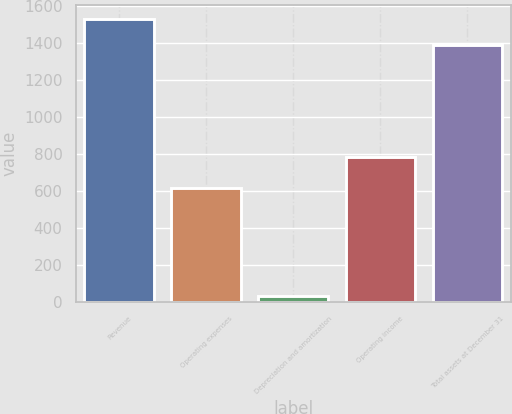Convert chart to OTSL. <chart><loc_0><loc_0><loc_500><loc_500><bar_chart><fcel>Revenue<fcel>Operating expenses<fcel>Depreciation and amortization<fcel>Operating income<fcel>Total assets at December 31<nl><fcel>1529.72<fcel>617.8<fcel>34.1<fcel>786.4<fcel>1389.3<nl></chart> 